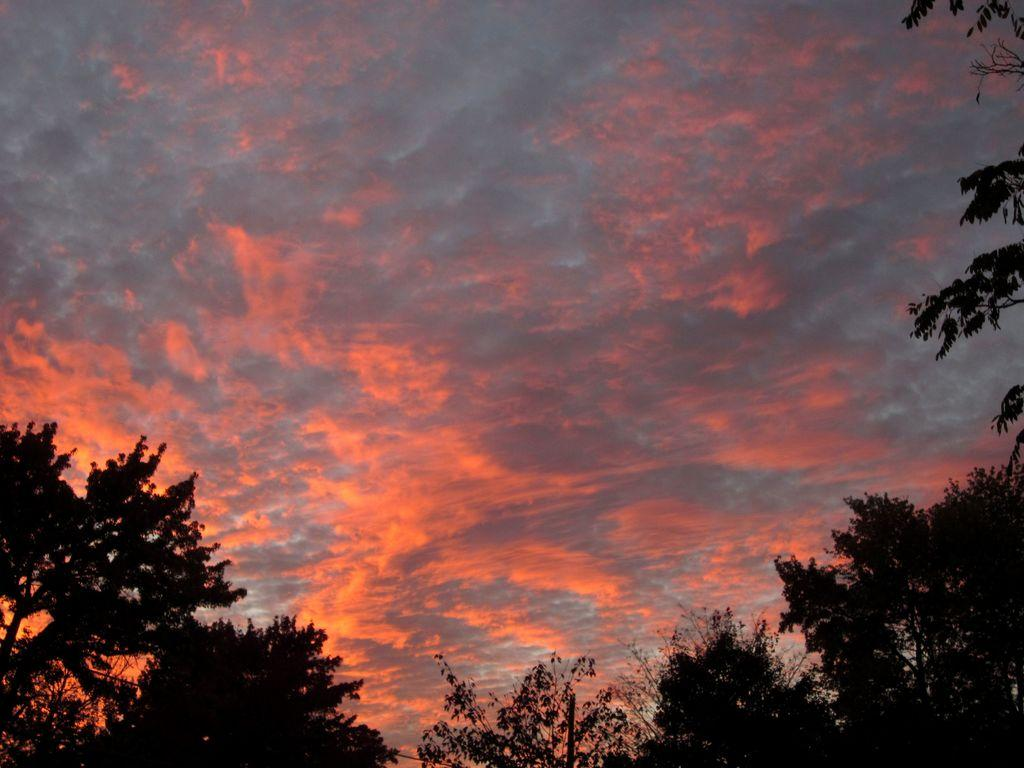What type of vegetation is present in the image? There is a group of trees in the image. What is visible in the background of the image? The sky is visible in the background of the image. How would you describe the sky's appearance in the image? The sky appears cloudy in the image. Where is the nearest hospital to the location of the trees in the image? The provided facts do not give any information about the location of the trees or the presence of a hospital, so it is not possible to answer that question. 